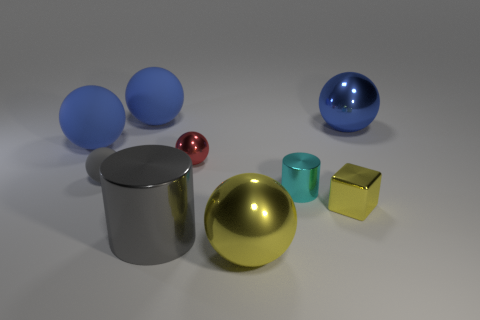There is a red sphere; is its size the same as the ball on the left side of the small matte sphere?
Offer a terse response. No. Are there fewer large yellow spheres behind the yellow block than big metal cylinders behind the cyan cylinder?
Ensure brevity in your answer.  No. There is a cyan cylinder that is to the right of the yellow ball; how big is it?
Provide a succinct answer. Small. Does the red thing have the same size as the gray rubber sphere?
Keep it short and to the point. Yes. What number of objects are left of the red object and in front of the tiny metallic block?
Your answer should be very brief. 1. What number of brown things are small metal blocks or big shiny balls?
Offer a very short reply. 0. What number of shiny things are tiny balls or red spheres?
Offer a terse response. 1. Are there any big brown objects?
Offer a very short reply. No. Does the cyan metal thing have the same shape as the big gray metal thing?
Ensure brevity in your answer.  Yes. How many things are in front of the big sphere in front of the gray thing behind the big cylinder?
Give a very brief answer. 0. 